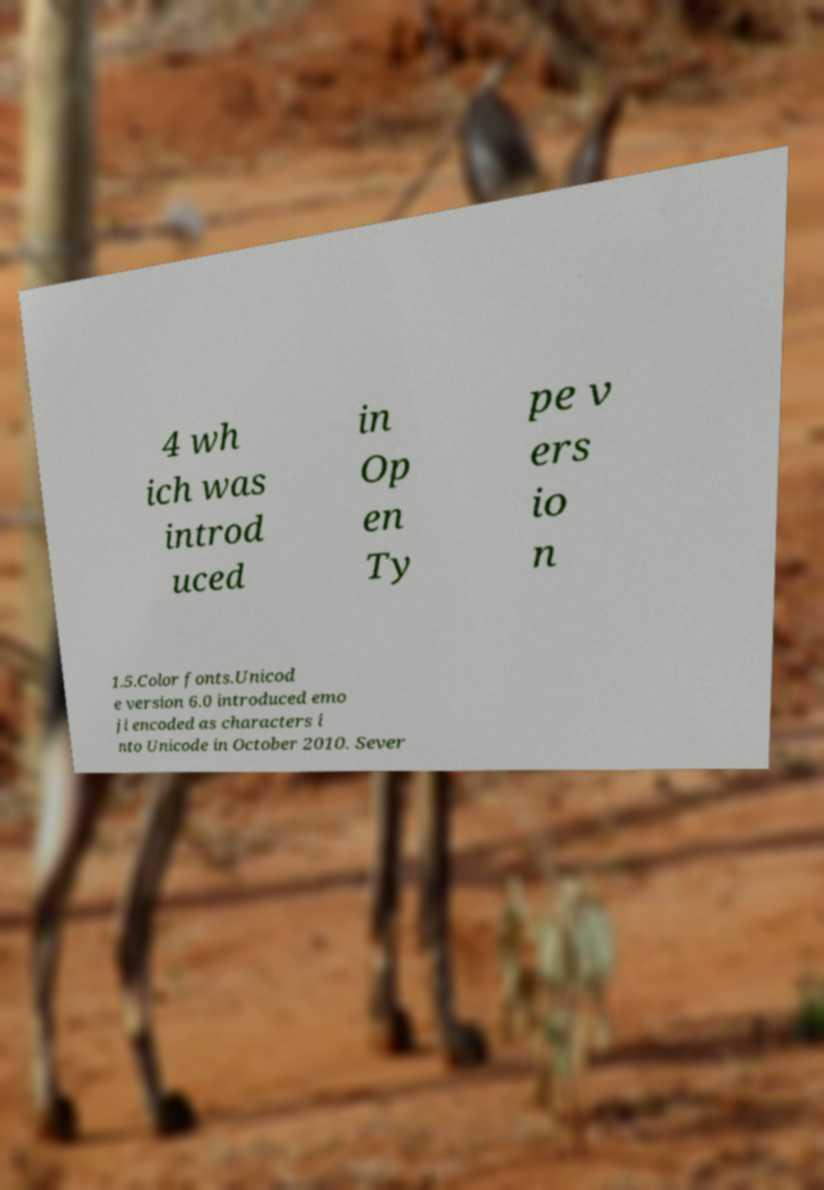I need the written content from this picture converted into text. Can you do that? 4 wh ich was introd uced in Op en Ty pe v ers io n 1.5.Color fonts.Unicod e version 6.0 introduced emo ji encoded as characters i nto Unicode in October 2010. Sever 